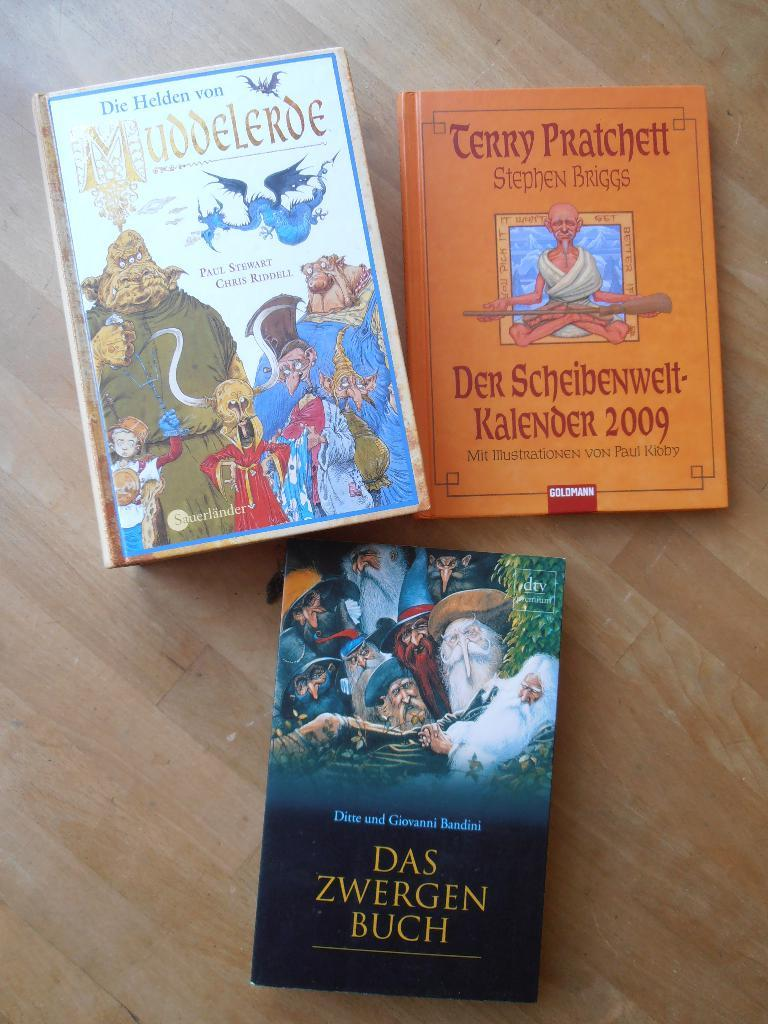<image>
Share a concise interpretation of the image provided. Three books entitled Der Scheibenwelf-Kalender 2009, Muddlerde, and Das Zwergen Buch. 